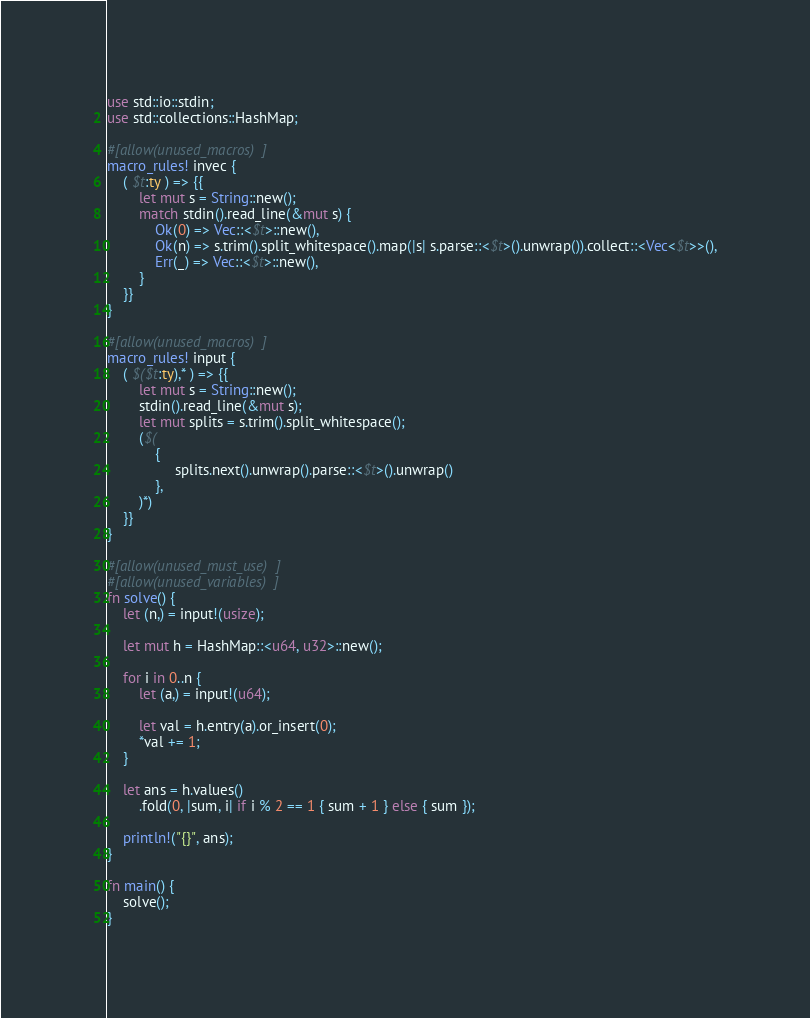Convert code to text. <code><loc_0><loc_0><loc_500><loc_500><_Rust_>use std::io::stdin;
use std::collections::HashMap;

#[allow(unused_macros)]
macro_rules! invec {
    ( $t:ty ) => {{
        let mut s = String::new();
        match stdin().read_line(&mut s) {
            Ok(0) => Vec::<$t>::new(),
            Ok(n) => s.trim().split_whitespace().map(|s| s.parse::<$t>().unwrap()).collect::<Vec<$t>>(),
            Err(_) => Vec::<$t>::new(),
        }
    }}
}

#[allow(unused_macros)]
macro_rules! input {
    ( $($t:ty),* ) => {{
        let mut s = String::new();
        stdin().read_line(&mut s);
        let mut splits = s.trim().split_whitespace();
        ($(
            {
                 splits.next().unwrap().parse::<$t>().unwrap()
            },
        )*)
    }}
}

#[allow(unused_must_use)]
#[allow(unused_variables)]
fn solve() {
    let (n,) = input!(usize);

    let mut h = HashMap::<u64, u32>::new();

    for i in 0..n {
        let (a,) = input!(u64);

        let val = h.entry(a).or_insert(0);
        *val += 1;
    }

    let ans = h.values()
        .fold(0, |sum, i| if i % 2 == 1 { sum + 1 } else { sum });

    println!("{}", ans);
}

fn main() {
    solve();
}
</code> 